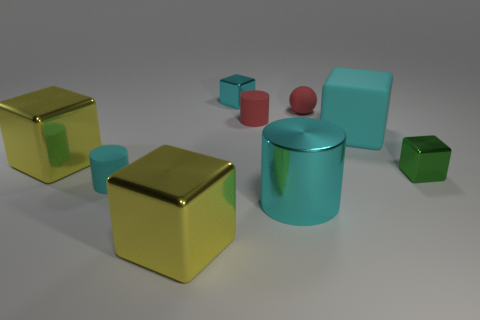What number of objects are big yellow metal cubes that are in front of the tiny green shiny thing or things that are behind the tiny red matte sphere?
Offer a terse response. 2. Are there the same number of yellow metal things to the right of the small red sphere and cyan cylinders?
Ensure brevity in your answer.  No. Do the cyan block on the right side of the small red matte cylinder and the cyan cylinder on the left side of the cyan metal cube have the same size?
Keep it short and to the point. No. How many other objects are the same size as the sphere?
Your answer should be very brief. 4. Are there any large yellow metal objects on the right side of the big yellow block on the right side of the yellow object behind the large cylinder?
Offer a terse response. No. What is the size of the cyan block on the right side of the small cyan block?
Offer a very short reply. Large. How big is the rubber cylinder to the left of the shiny cube that is in front of the tiny shiny object that is in front of the rubber cube?
Provide a short and direct response. Small. There is a tiny block on the right side of the small shiny object that is behind the small sphere; what is its color?
Offer a terse response. Green. There is another tiny thing that is the same shape as the tiny green thing; what material is it?
Your answer should be very brief. Metal. Is there anything else that has the same material as the small cyan cube?
Offer a very short reply. Yes. 